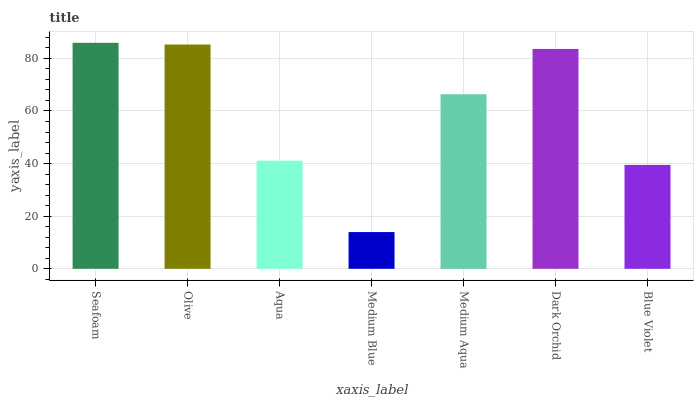Is Medium Blue the minimum?
Answer yes or no. Yes. Is Seafoam the maximum?
Answer yes or no. Yes. Is Olive the minimum?
Answer yes or no. No. Is Olive the maximum?
Answer yes or no. No. Is Seafoam greater than Olive?
Answer yes or no. Yes. Is Olive less than Seafoam?
Answer yes or no. Yes. Is Olive greater than Seafoam?
Answer yes or no. No. Is Seafoam less than Olive?
Answer yes or no. No. Is Medium Aqua the high median?
Answer yes or no. Yes. Is Medium Aqua the low median?
Answer yes or no. Yes. Is Blue Violet the high median?
Answer yes or no. No. Is Blue Violet the low median?
Answer yes or no. No. 